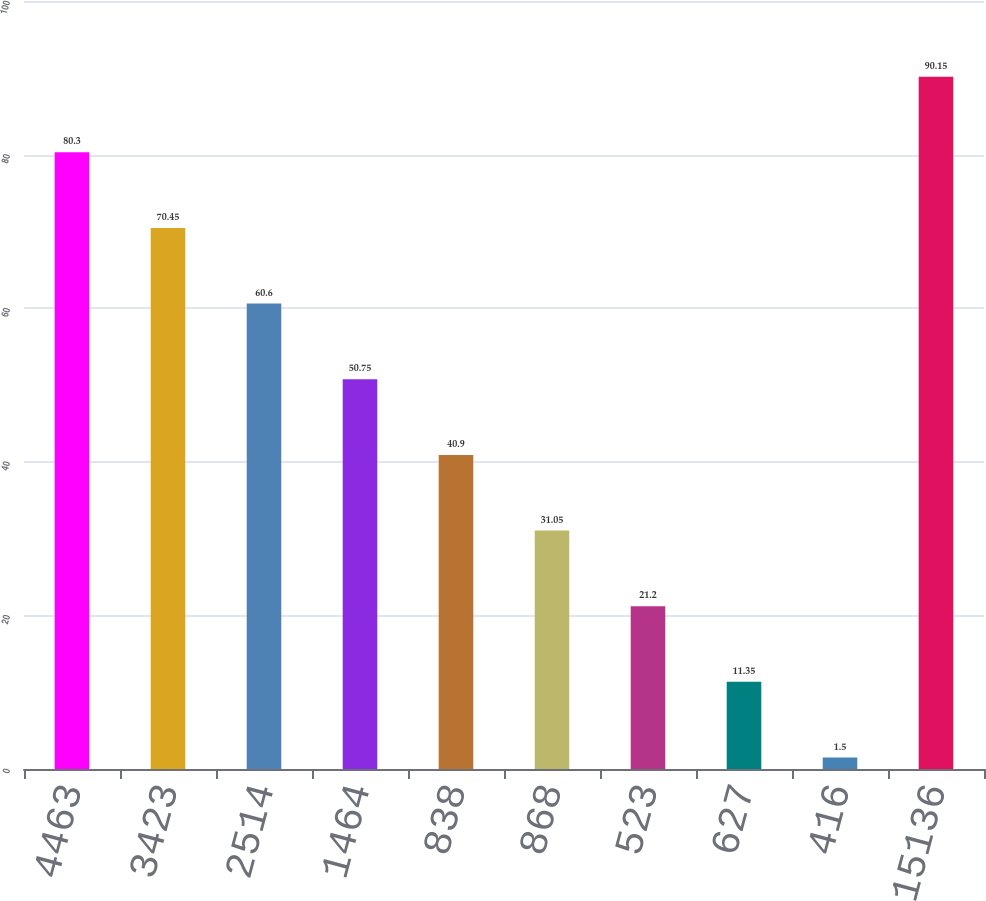Convert chart. <chart><loc_0><loc_0><loc_500><loc_500><bar_chart><fcel>4463<fcel>3423<fcel>2514<fcel>1464<fcel>838<fcel>868<fcel>523<fcel>627<fcel>416<fcel>15136<nl><fcel>80.3<fcel>70.45<fcel>60.6<fcel>50.75<fcel>40.9<fcel>31.05<fcel>21.2<fcel>11.35<fcel>1.5<fcel>90.15<nl></chart> 